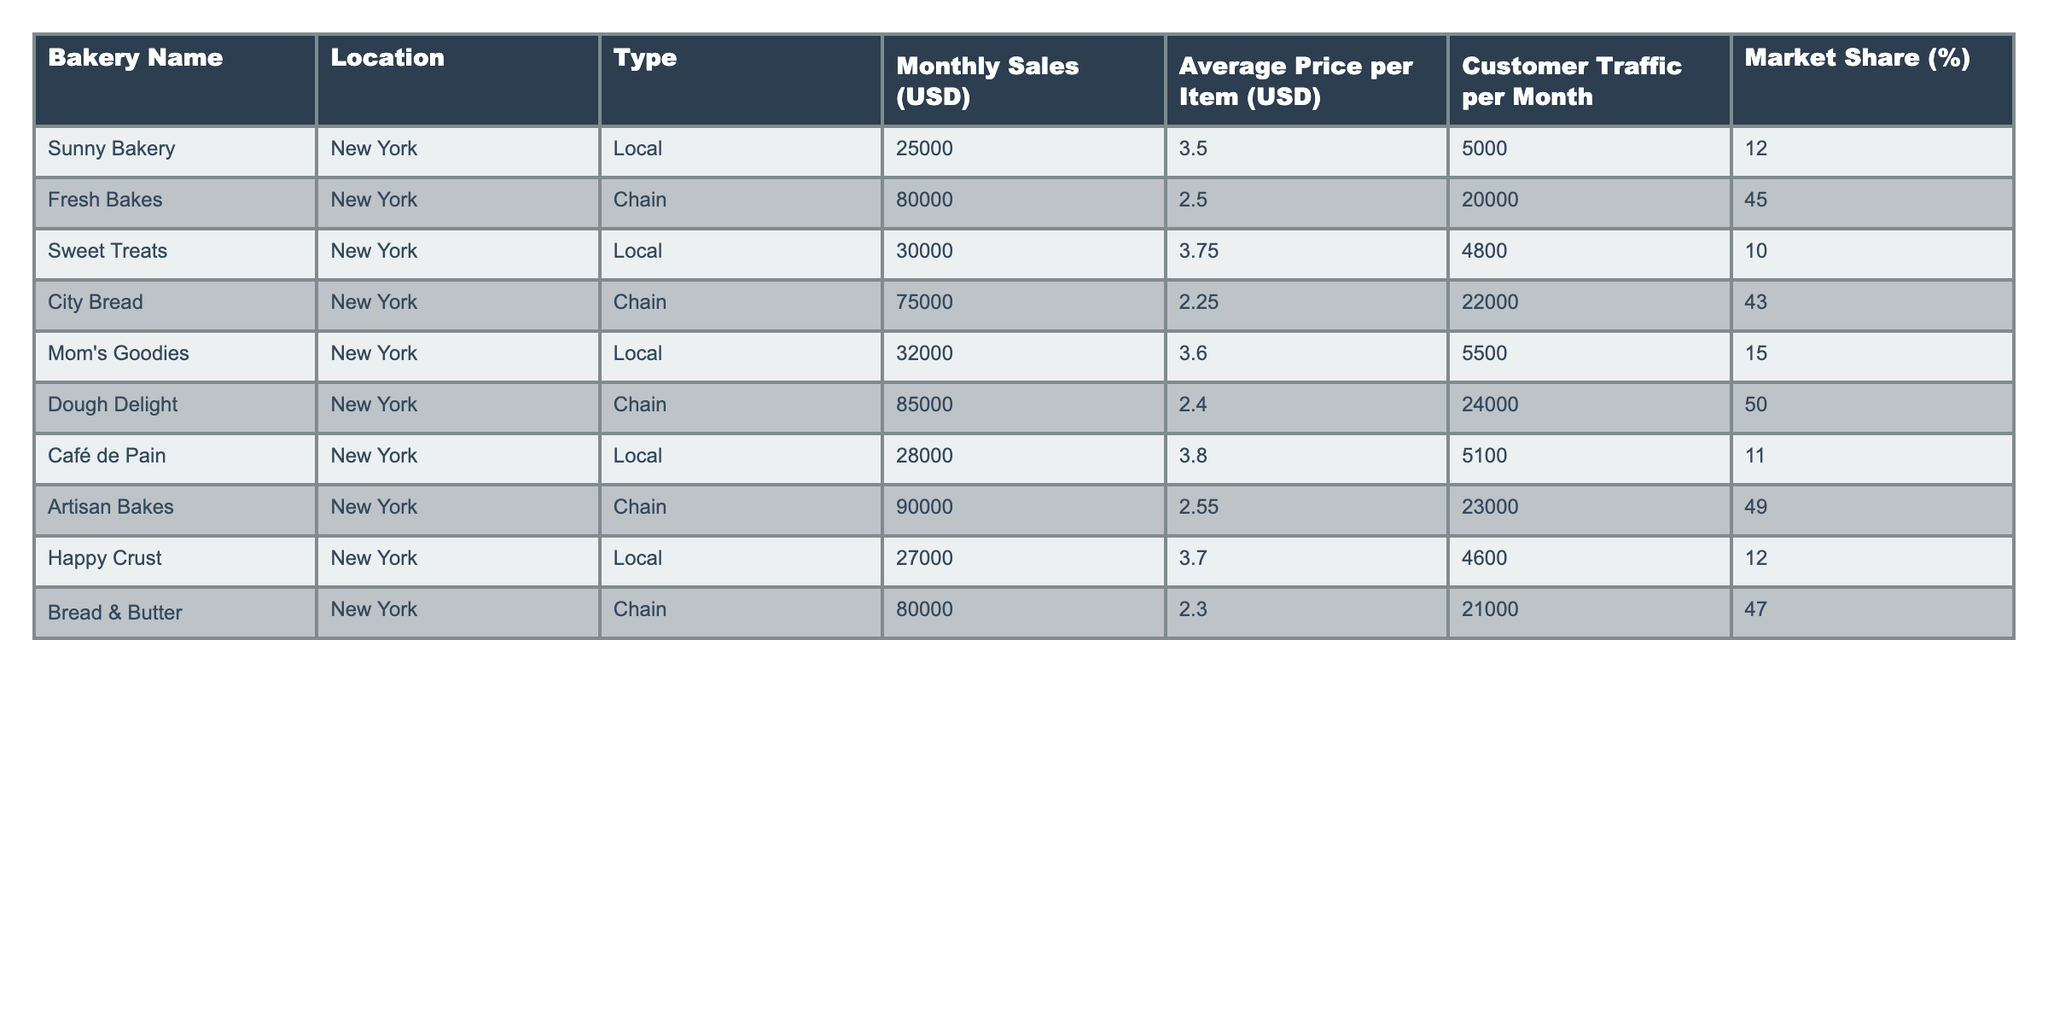What is the monthly sales for Dough Delight? The table lists the monthly sales for each bakery; for Dough Delight, it shows $85,000.
Answer: 85,000 Which bakery has the highest market share? By comparing the market share percentages listed, Dough Delight has the highest at 50%.
Answer: 50% What is the average price per item for local bakeries? The average price for the local bakeries is calculated as follows: (3.50 + 3.75 + 3.60 + 3.80 + 3.70) / 5 = 3.63.
Answer: 3.63 Which chain bakery has the lowest average price per item? Among the chain bakeries, City Bread has the lowest average price per item at $2.25.
Answer: 2.25 What is the combined monthly sales of all chain bakeries? The monthly sales for chain bakeries are summed: 80,000 + 75,000 + 85,000 + 90,000 + 80,000 = 410,000.
Answer: 410,000 Is Happy Crust's sales higher than Sweet Treats? Happy Crust has sales of $27,000 while Sweet Treats has $30,000. Thus, the statement is false.
Answer: No How many customers does Artisan Bakes attract per month compared to Mom's Goodies? Artisan Bakes attracts 23,000 customers per month, and Mom's Goodies attracts 5,500. Artisan Bakes draws significantly more customers.
Answer: More customers What is the difference in monthly sales between the highest and lowest local bakery? The highest local bakery is Mom's Goodies at $32,000 and the lowest is Sunny Bakery at $25,000. The difference is $32,000 - $25,000 = $7,000.
Answer: 7,000 What percentage of total market share is held by local bakeries? The total market share for local bakeries is summed: 12 + 10 + 15 + 11 + 12 = 60%.
Answer: 60% Which type of bakery (chain or local) attracts more customer traffic on average? The average for local bakeries is (5000 + 4800 + 5500 + 5100 + 4600) / 5 = 4910, and for chain bakeries, it's (20000 + 22000 + 24000 + 23000 + 21000) / 5 = 22000. Chain bakeries attract more on average.
Answer: Chain bakeries What is the total monthly sales for local bakeries compared to chain bakeries? Local bakeries' total is 25,000 + 30,000 + 32,000 + 28,000 + 27,000 = 142,000, while chain bakeries' total is 410,000. Chain bakeries have significantly higher sales.
Answer: Chain bakeries 